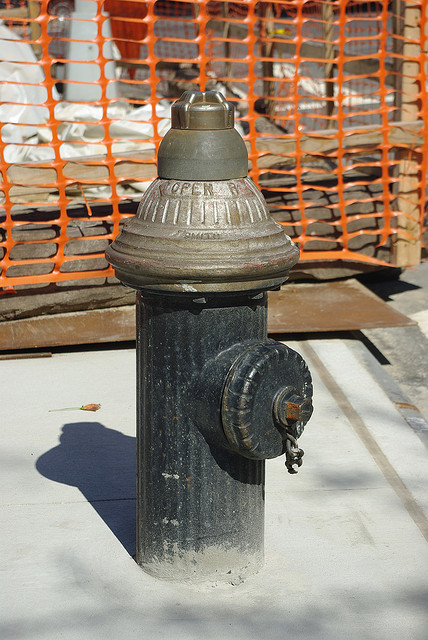Identify the text displayed in this image. OPEN 